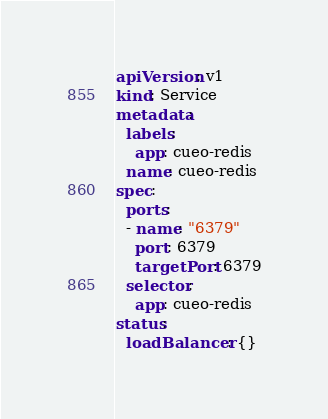<code> <loc_0><loc_0><loc_500><loc_500><_YAML_>apiVersion: v1
kind: Service
metadata:
  labels:
    app: cueo-redis
  name: cueo-redis
spec:
  ports:
  - name: "6379"
    port: 6379
    targetPort: 6379
  selector:
    app: cueo-redis
status:
  loadBalancer: {}
</code> 